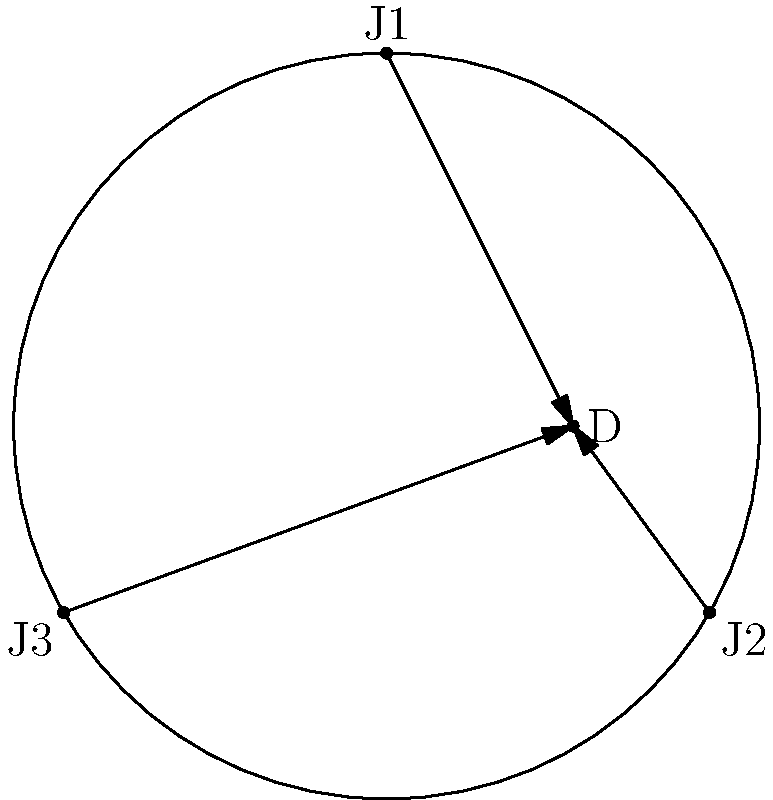In a circular show ring with a radius of 10 meters, three judges (J1, J2, and J3) are positioned on the ring's edge. J1 is at (0,10), J2 at (8.66,-5), and J3 at (-8.66,-5). A dog (D) is positioned at (5,0). Calculate the angle between the sightlines of J1 and J2 to the dog, rounded to the nearest degree. To find the angle between the sightlines, we'll follow these steps:

1) First, we need to find the vectors from J1 to D and J2 to D.

   $\vec{J1D} = D - J1 = (5,0) - (0,10) = (5,-10)$
   $\vec{J2D} = D - J2 = (5,0) - (8.66,-5) = (-3.66,5)$

2) Now, we can use the dot product formula to find the angle between these vectors:

   $\cos \theta = \frac{\vec{J1D} \cdot \vec{J2D}}{|\vec{J1D}||\vec{J2D}|}$

3) Calculate the dot product:
   
   $\vec{J1D} \cdot \vec{J2D} = (5)(-3.66) + (-10)(5) = -68.3$

4) Calculate the magnitudes:

   $|\vec{J1D}| = \sqrt{5^2 + (-10)^2} = \sqrt{125} = 11.18$
   $|\vec{J2D}| = \sqrt{(-3.66)^2 + 5^2} = \sqrt{38.4356} = 6.20$

5) Substitute into the formula:

   $\cos \theta = \frac{-68.3}{11.18 \times 6.20} = -0.9851$

6) Take the inverse cosine (arccos) and convert to degrees:

   $\theta = \arccos(-0.9851) \times \frac{180}{\pi} = 170.1°$

7) Rounding to the nearest degree:

   $\theta \approx 170°$
Answer: 170° 